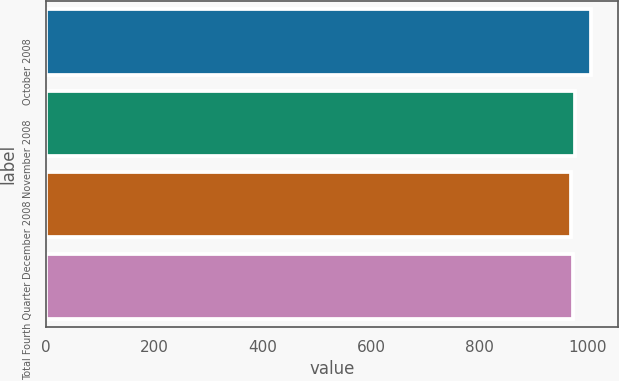Convert chart. <chart><loc_0><loc_0><loc_500><loc_500><bar_chart><fcel>October 2008<fcel>November 2008<fcel>December 2008<fcel>Total Fourth Quarter<nl><fcel>1005.3<fcel>975.38<fcel>967.9<fcel>971.64<nl></chart> 